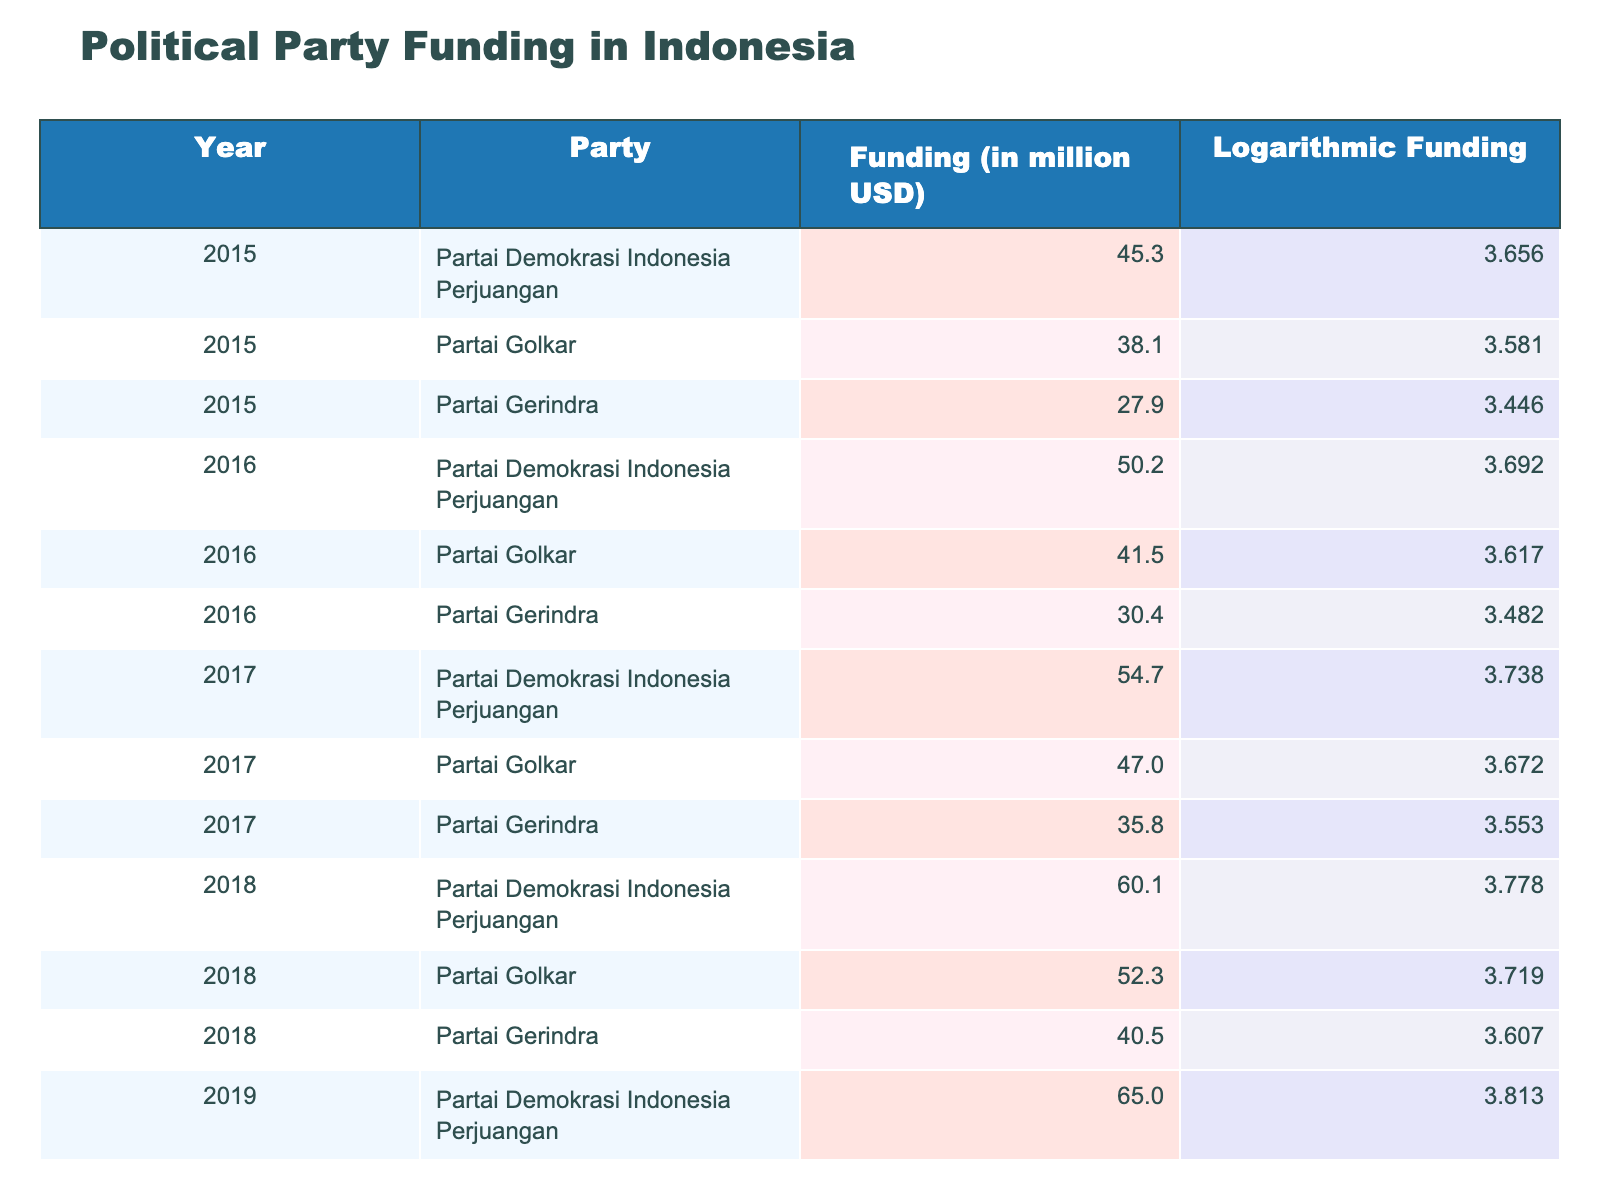What was the funding for Partai Gerindra in 2018? The table indicates that the funding for Partai Gerindra in 2018 is listed in the corresponding row under the "Funding (in million USD)" column, which shows a value of 40.5 million USD.
Answer: 40.5 Which party had the highest funding in 2019? Looking closely at the funding values for 2019, Partai Demokrasi Indonesia Perjuangan has the highest value at 65.0 million USD, exceeding the other parties in that year.
Answer: Partai Demokrasi Indonesia Perjuangan What is the average funding for Partai Golkar over the years provided? First, we identify the funding values for Partai Golkar across the years (38.1 in 2015, 41.5 in 2016, 47.0 in 2017, 52.3 in 2018, and 56.8 in 2019). The sum of these values is 235.7 million USD. Since there are 5 years, we calculate the average: 235.7 / 5 = 47.14 million USD.
Answer: 47.14 Did Partai Demokrasi Indonesia Perjuangan experience an increase in funding every year from 2015 to 2019? By examining the funding amounts for each year (45.3 in 2015, 50.2 in 2016, 54.7 in 2017, 60.1 in 2018, and 65.0 in 2019), we see that each subsequent year shows a higher funding value. Therefore, the statement is true.
Answer: Yes What was the total funding for all parties in 2017? We find the funding for each party in 2017: Partai Demokrasi Indonesia Perjuangan (54.7), Partai Golkar (47.0), and Partai Gerindra (35.8). Summing these gives us: 54.7 + 47.0 + 35.8 = 137.5 million USD, which represents the total funding for all parties in that year.
Answer: 137.5 How much more funding did Partai Demokrasi Indonesia Perjuangan receive in 2019 compared to 2015? In 2019, the funding was 65.0 million USD, and in 2015 it was 45.3 million USD. Calculating the difference: 65.0 - 45.3 = 19.7 million USD shows that there was an increase of 19.7 million USD in funding over those years.
Answer: 19.7 Was the logarithmic funding for each party consistently increasing from 2015 to 2019? By reviewing the logarithmic values, we find that for each party the logarithmic funding increases from 2015 to 2019. This shows a consistent upward trend across the years for all parties.
Answer: Yes Which party had the lowest logarithmic funding in 2016? In 2016, we check the logarithmic values for each party from the table. Partai Gerindra has the lowest logarithmic funding at 3.482 compared to the other parties.
Answer: Partai Gerindra 